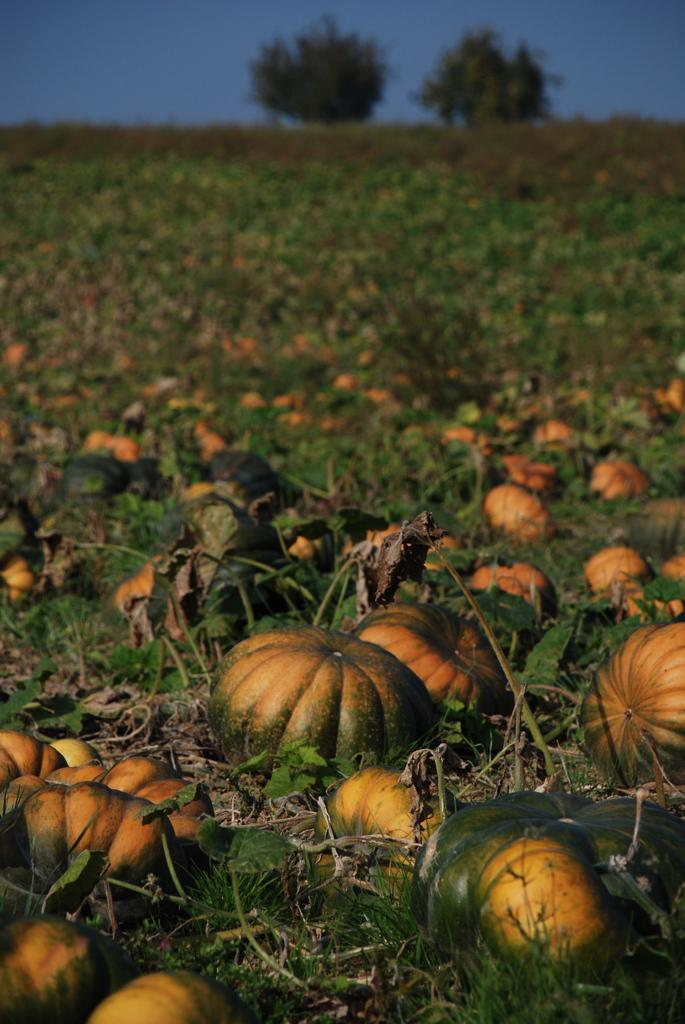What is the main subject of the image? The main subject of the image is many pumpkins. What can be seen in the background of the image? There are two trees in the background of the image. What part of the natural environment is visible in the image? The sky is visible in the image. What type of skin can be seen on the pumpkins in the image? The image does not show the skin of the pumpkins, only their outer appearance. 